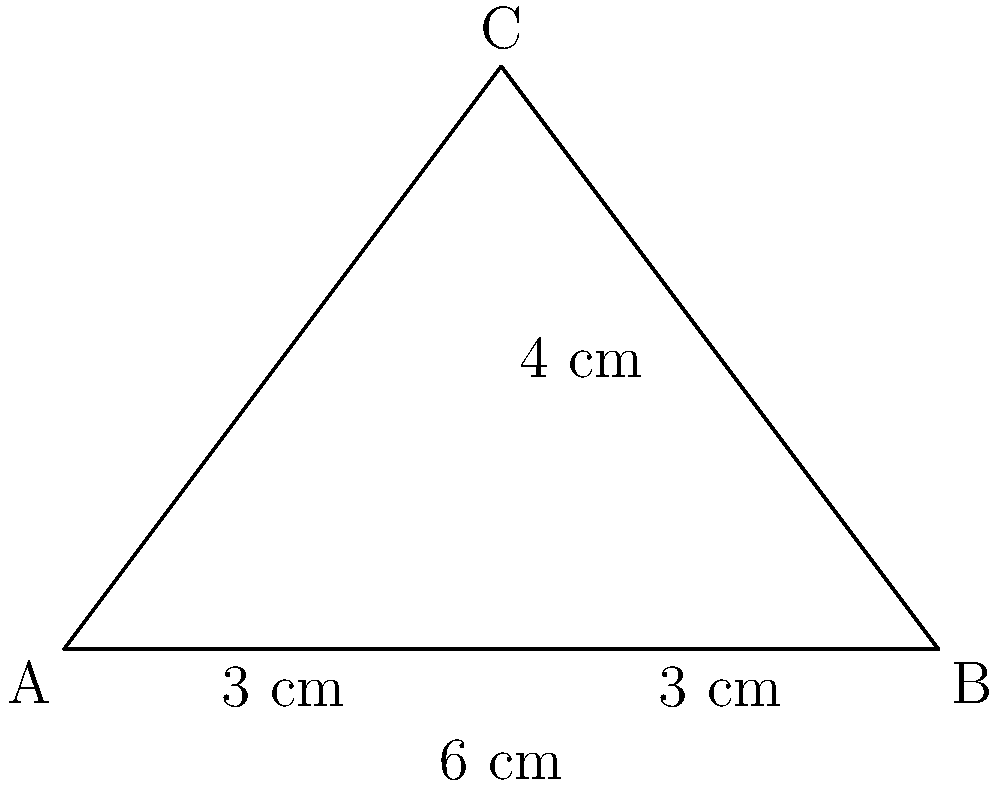In a property dispute case, you're presented with a triangular plot of land. The base of the triangle measures 6 cm, and a perpendicular line from the apex to the base divides the base into two equal segments of 3 cm each. If this perpendicular line measures 4 cm, what is the area of the triangular plot in square centimeters? To solve this problem, we'll use the formula for the area of a triangle:

$$A = \frac{1}{2} \times base \times height$$

Step 1: Identify the known values
- Base of the triangle = 6 cm
- Height of the triangle (perpendicular line) = 4 cm

Step 2: Apply the formula
$$A = \frac{1}{2} \times 6 \times 4$$

Step 3: Calculate the area
$$A = \frac{1}{2} \times 24 = 12$$

Therefore, the area of the triangular plot is 12 square centimeters.

Note: In a real property dispute case, you would need to convert these measurements to actual land units, but for the purpose of this trigonometry question, we're working with the given units.
Answer: 12 sq cm 